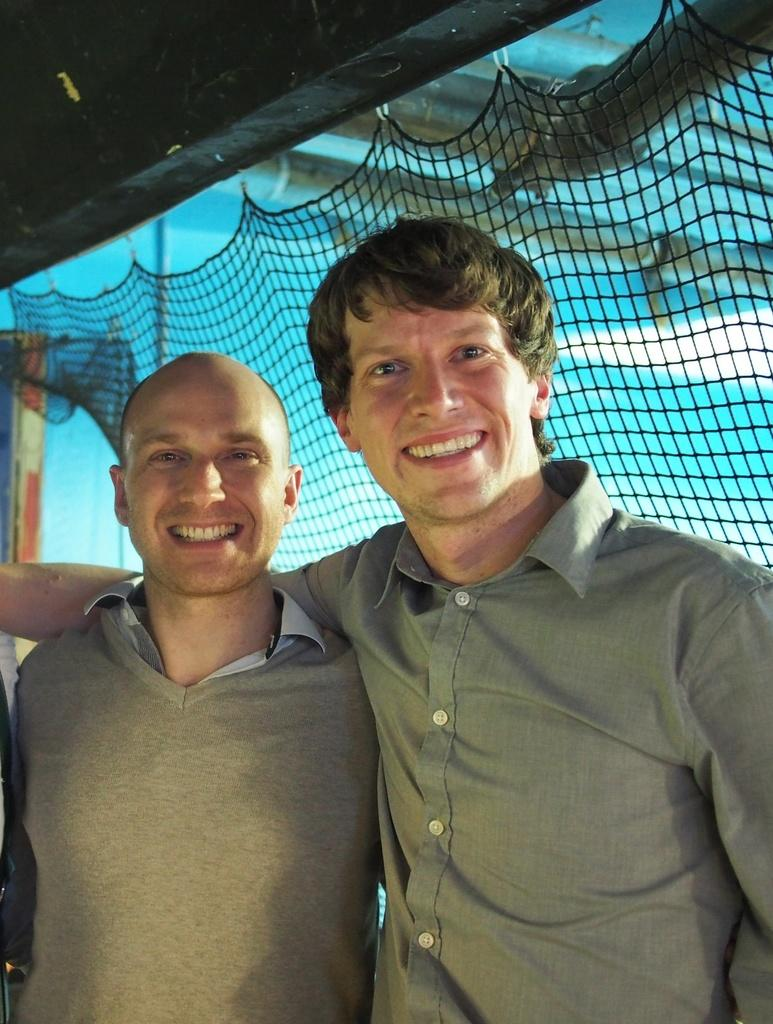Who is present in the image? There are men in the image. What is the facial expression of the men? The men are smiling. What can be seen in the background of the image? There is a net and a wall in the background of the image. Can you describe the setting of the image? The image appears to be an indoor scene. What type of boot is being used to measure the year in the image? There is no boot or measurement of the year present in the image. 